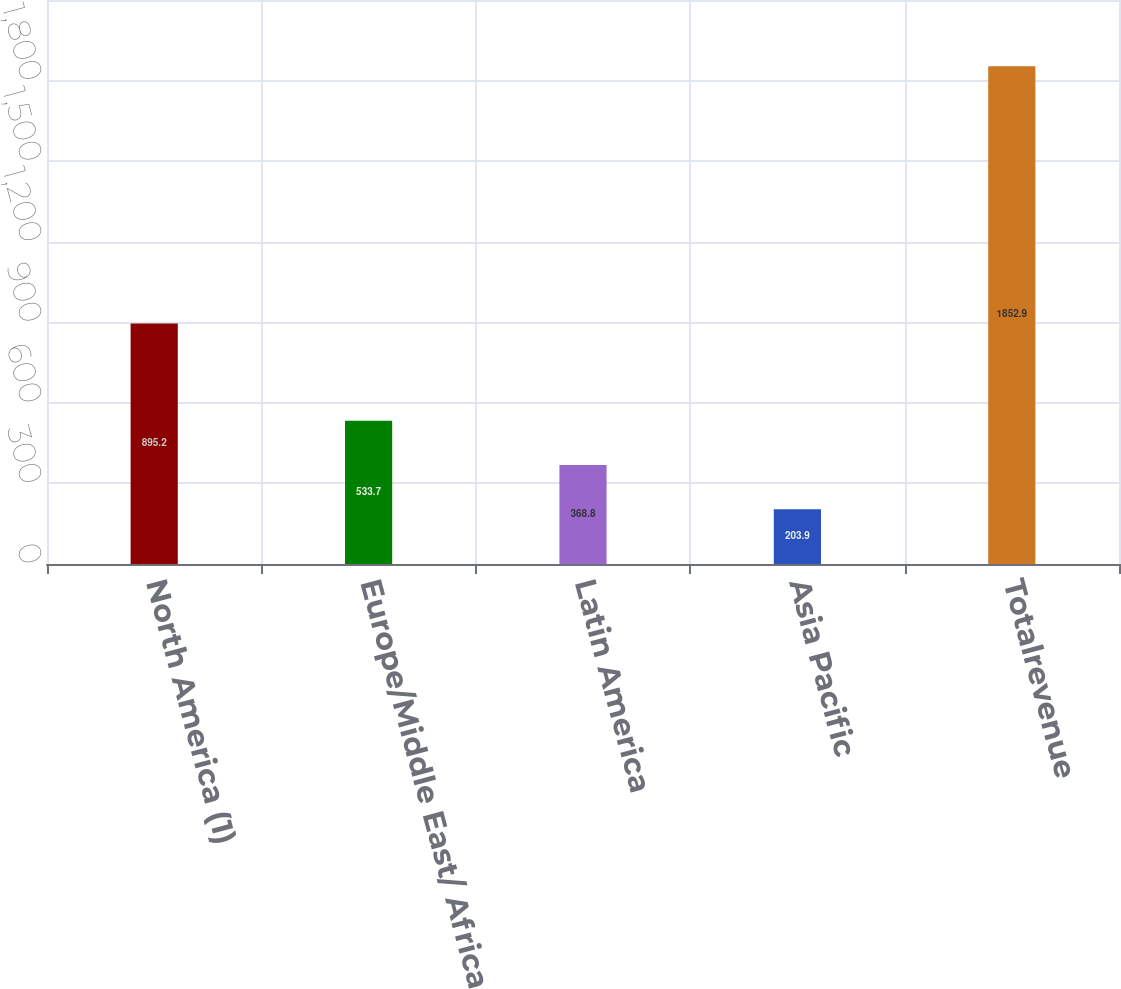Convert chart. <chart><loc_0><loc_0><loc_500><loc_500><bar_chart><fcel>North America (1)<fcel>Europe/Middle East/ Africa<fcel>Latin America<fcel>Asia Pacific<fcel>Totalrevenue<nl><fcel>895.2<fcel>533.7<fcel>368.8<fcel>203.9<fcel>1852.9<nl></chart> 